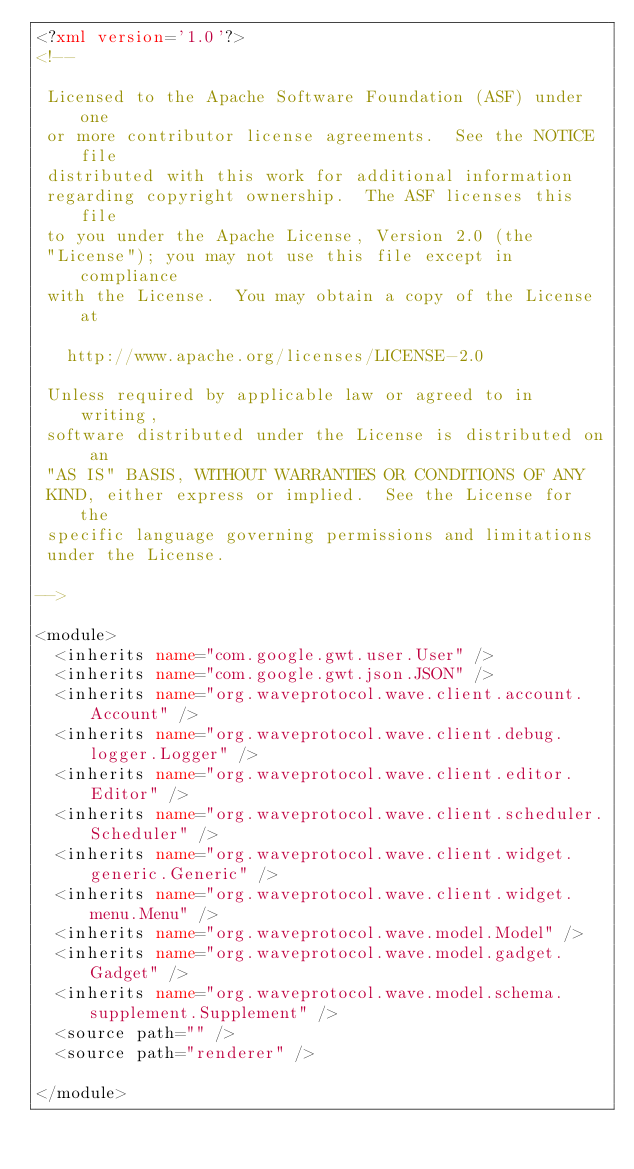Convert code to text. <code><loc_0><loc_0><loc_500><loc_500><_XML_><?xml version='1.0'?>
<!--

 Licensed to the Apache Software Foundation (ASF) under one
 or more contributor license agreements.  See the NOTICE file
 distributed with this work for additional information
 regarding copyright ownership.  The ASF licenses this file
 to you under the Apache License, Version 2.0 (the
 "License"); you may not use this file except in compliance
 with the License.  You may obtain a copy of the License at

   http://www.apache.org/licenses/LICENSE-2.0

 Unless required by applicable law or agreed to in writing,
 software distributed under the License is distributed on an
 "AS IS" BASIS, WITHOUT WARRANTIES OR CONDITIONS OF ANY
 KIND, either express or implied.  See the License for the
 specific language governing permissions and limitations
 under the License.

-->

<module>
  <inherits name="com.google.gwt.user.User" />
  <inherits name="com.google.gwt.json.JSON" />
  <inherits name="org.waveprotocol.wave.client.account.Account" />
  <inherits name="org.waveprotocol.wave.client.debug.logger.Logger" />
  <inherits name="org.waveprotocol.wave.client.editor.Editor" />
  <inherits name="org.waveprotocol.wave.client.scheduler.Scheduler" />
  <inherits name="org.waveprotocol.wave.client.widget.generic.Generic" />
  <inherits name="org.waveprotocol.wave.client.widget.menu.Menu" />
  <inherits name="org.waveprotocol.wave.model.Model" />
  <inherits name="org.waveprotocol.wave.model.gadget.Gadget" />
  <inherits name="org.waveprotocol.wave.model.schema.supplement.Supplement" />
  <source path="" />
  <source path="renderer" />

</module>
</code> 